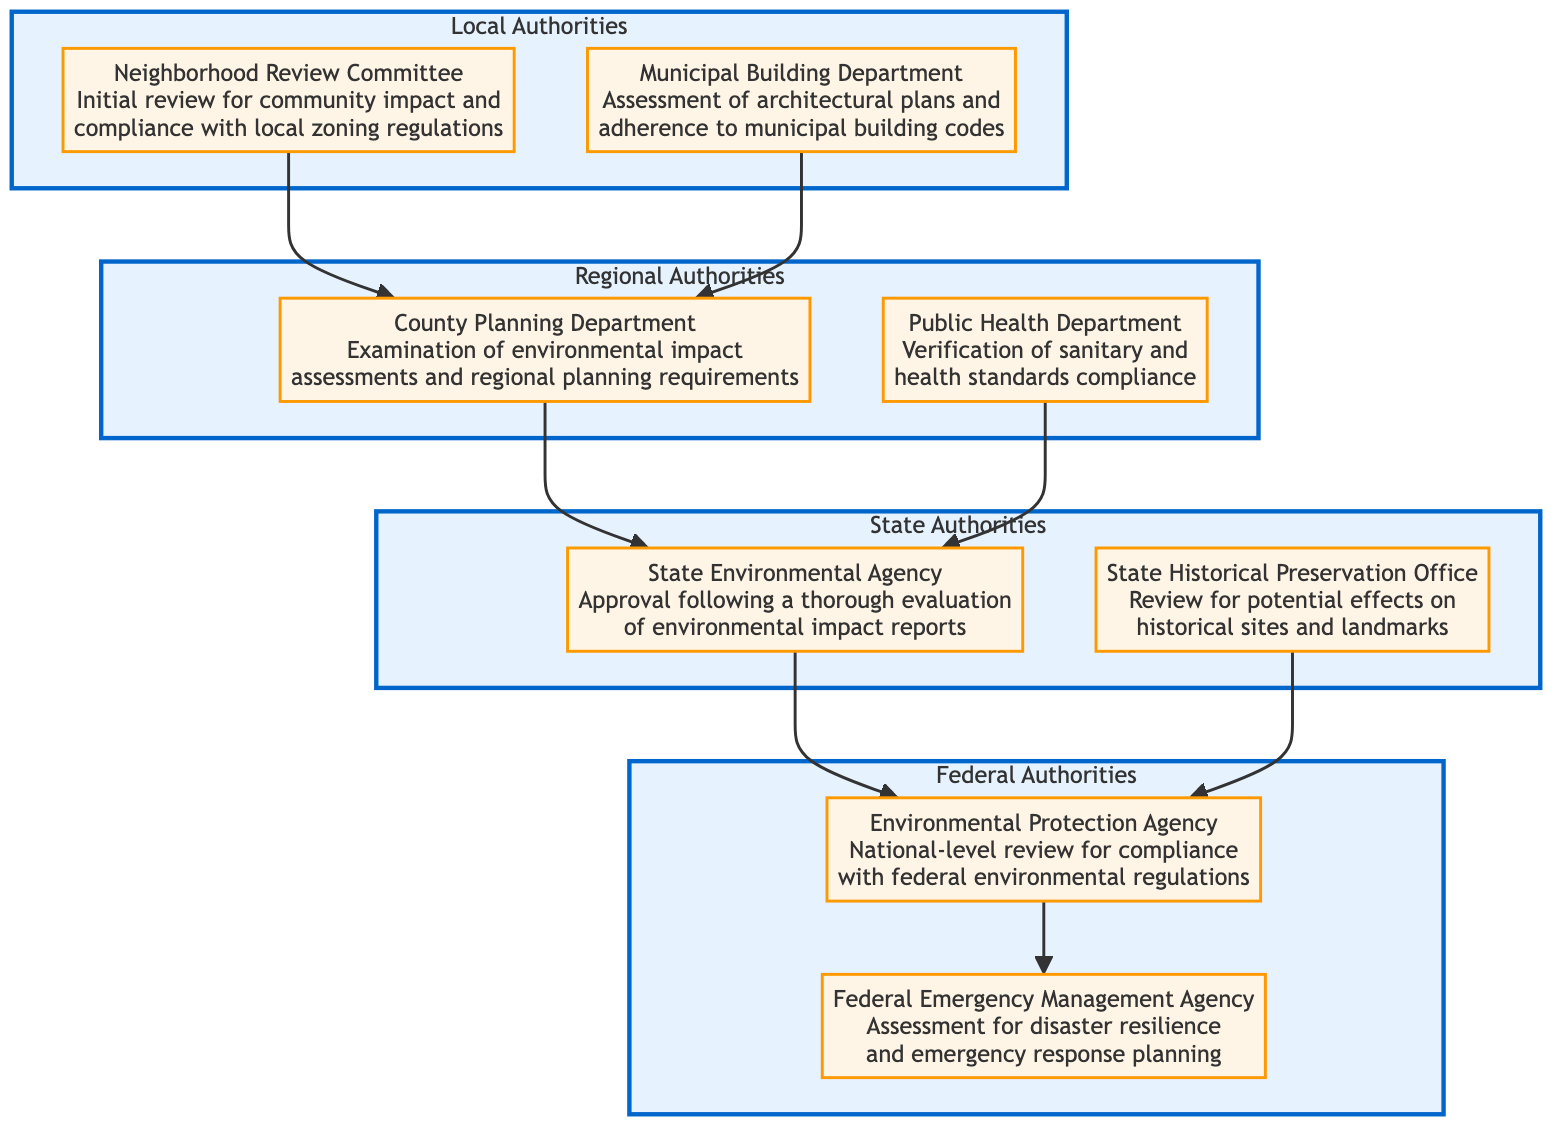What is the top level in the hierarchy? The top level in the hierarchy represents "Federal Authorities" as it is the highest hierarchy visible in the flowchart.
Answer: Federal Authorities How many local authorities are listed? There are two local authorities represented in the diagram: "Neighborhood Review Committee" and "Municipal Building Department."
Answer: 2 What action follows the "County Planning Department"? The action that follows "County Planning Department" is "State Environmental Agency," which is the next tier in the approval process.
Answer: State Environmental Agency What is the purpose of the "Public Health Department"? The purpose of "Public Health Department" is clearly stated as the verification of sanitary and health standards compliance.
Answer: Verification of sanitary and health standards compliance Which Federal authority assesses disaster resilience? The federal authority that assesses disaster resilience is "Federal Emergency Management Agency."
Answer: Federal Emergency Management Agency What actions precede "State Environmental Agency"? The actions that precede "State Environmental Agency" are "County Planning Department" and "Public Health Department," indicating that both must occur first.
Answer: County Planning Department and Public Health Department How many total actions are listed under "State Authorities"? There are two actions listed under "State Authorities": "State Environmental Agency" and "State Historical Preservation Office."
Answer: 2 Which action is reviewed for compliance with federal environmental regulations? The action reviewed for compliance with federal environmental regulations is "Environmental Protection Agency."
Answer: Environmental Protection Agency What is the relationship between "Municipal Building Department" and "County Planning Department"? The relationship is that both the "Municipal Building Department" and "Neighborhood Review Committee" direct their actions to the "County Planning Department," indicating these are initial steps leading to regional authority review.
Answer: Both lead to County Planning Department What process follows the review by the "Neighborhood Review Committee"? The process that follows is the assessment by the "Municipal Building Department," indicating that this must happen after community review.
Answer: Assessment by Municipal Building Department 